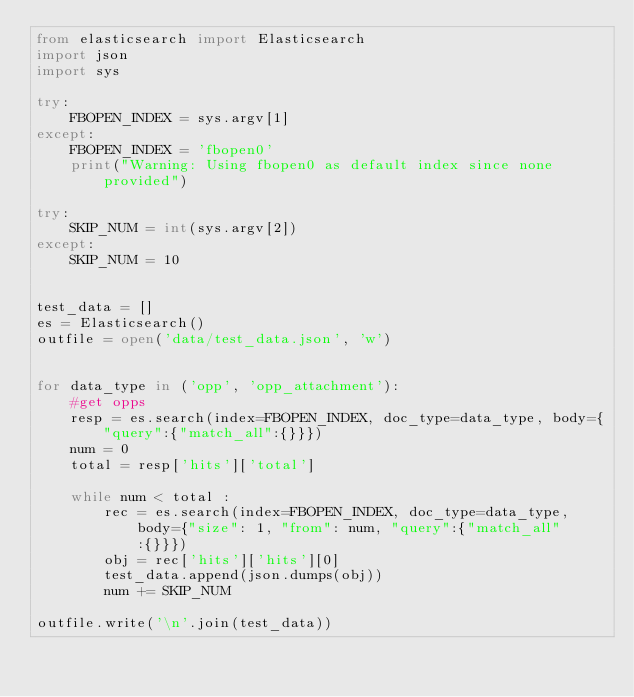Convert code to text. <code><loc_0><loc_0><loc_500><loc_500><_Python_>from elasticsearch import Elasticsearch
import json
import sys

try:
    FBOPEN_INDEX = sys.argv[1]
except:
    FBOPEN_INDEX = 'fbopen0'
    print("Warning: Using fbopen0 as default index since none provided")

try:
    SKIP_NUM = int(sys.argv[2])
except:
    SKIP_NUM = 10


test_data = []
es = Elasticsearch()
outfile = open('data/test_data.json', 'w')


for data_type in ('opp', 'opp_attachment'):
    #get opps 
    resp = es.search(index=FBOPEN_INDEX, doc_type=data_type, body={"query":{"match_all":{}}})
    num = 0 
    total = resp['hits']['total']

    while num < total :
        rec = es.search(index=FBOPEN_INDEX, doc_type=data_type, body={"size": 1, "from": num, "query":{"match_all":{}}})
        obj = rec['hits']['hits'][0]
        test_data.append(json.dumps(obj))
        num += SKIP_NUM
        
outfile.write('\n'.join(test_data))
</code> 